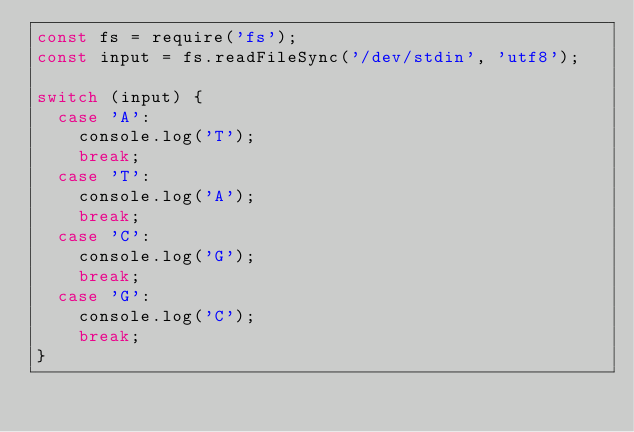Convert code to text. <code><loc_0><loc_0><loc_500><loc_500><_JavaScript_>const fs = require('fs');
const input = fs.readFileSync('/dev/stdin', 'utf8');

switch (input) {
  case 'A':
    console.log('T');
    break;
  case 'T':
    console.log('A');
    break;
  case 'C':
    console.log('G');
    break;
  case 'G':
    console.log('C');
    break;
}</code> 